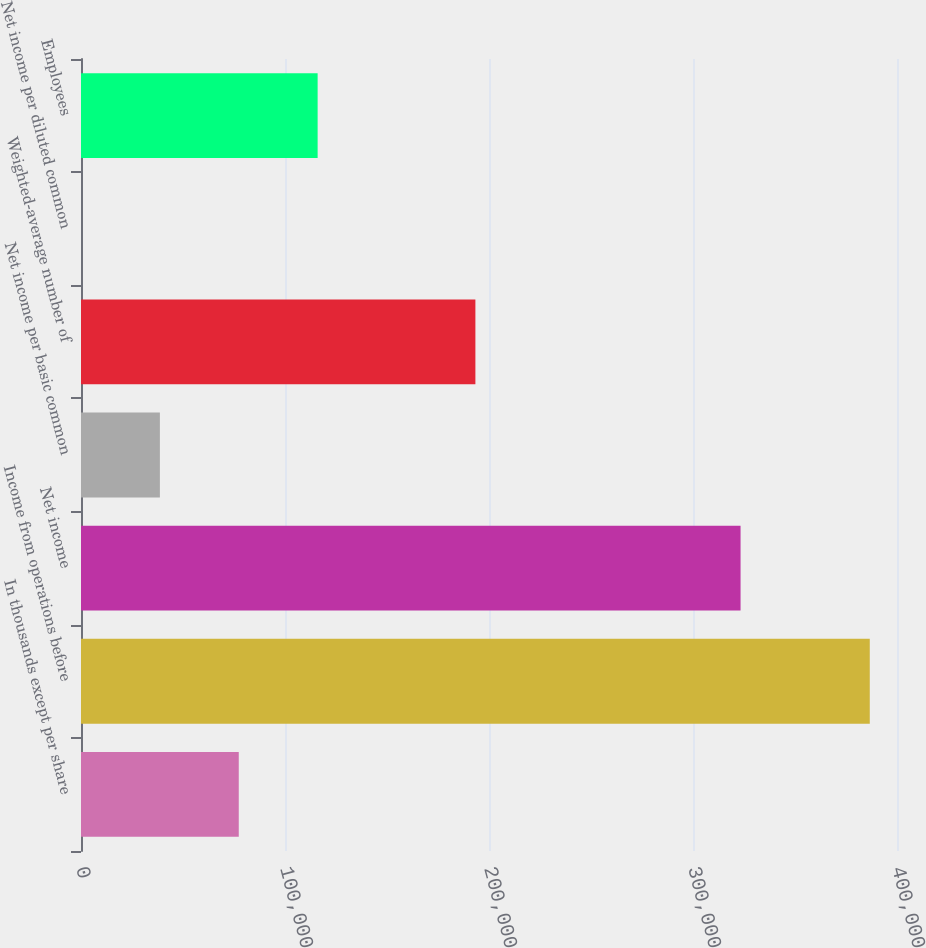Convert chart. <chart><loc_0><loc_0><loc_500><loc_500><bar_chart><fcel>In thousands except per share<fcel>Income from operations before<fcel>Net income<fcel>Net income per basic common<fcel>Weighted-average number of<fcel>Net income per diluted common<fcel>Employees<nl><fcel>77333.1<fcel>386652<fcel>323313<fcel>38668.2<fcel>193328<fcel>3.34<fcel>115998<nl></chart> 